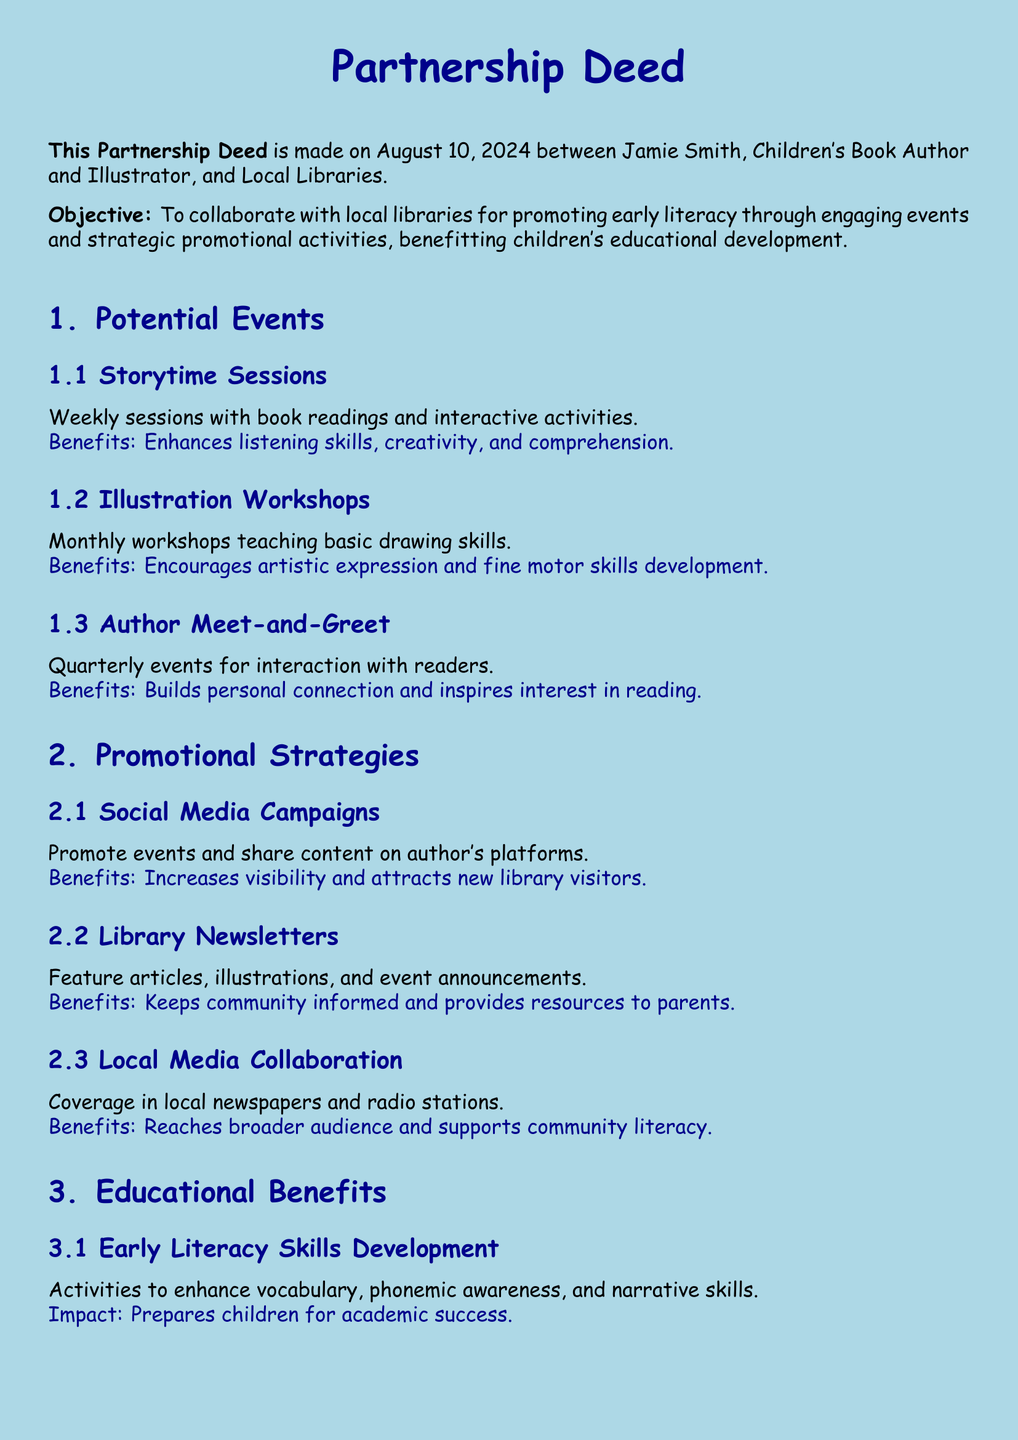What is the name of the author? The document states that the author is Jamie Smith.
Answer: Jamie Smith What is the main objective of the partnership? The partnership aims to promote early literacy through engaging events and promotional activities.
Answer: Promote early literacy How often will the Storytime Sessions be held? The document mentions that Storytime Sessions will be weekly.
Answer: Weekly What type of workshops are planned? A specific type of workshop mentioned is Illustration Workshops.
Answer: Illustration Workshops How many Author Meet-and-Greet events are planned each year? The document states there will be quarterly events, which means four events per year.
Answer: Four What is one benefit of the Social Media Campaigns? The document notes that it increases visibility and attracts new library visitors.
Answer: Increases visibility What kind of support will be created according to the document? The document mentions creating a community-centered approach to literacy.
Answer: Community-centered approach What is one impact of family engagement mentioned? The document states that it enhances the home learning environment and parent-child bond.
Answer: Enhances home learning environment How will local media be utilized in the proposal? The partnership includes coverage in local newspapers and radio stations.
Answer: Local newspapers and radio stations 